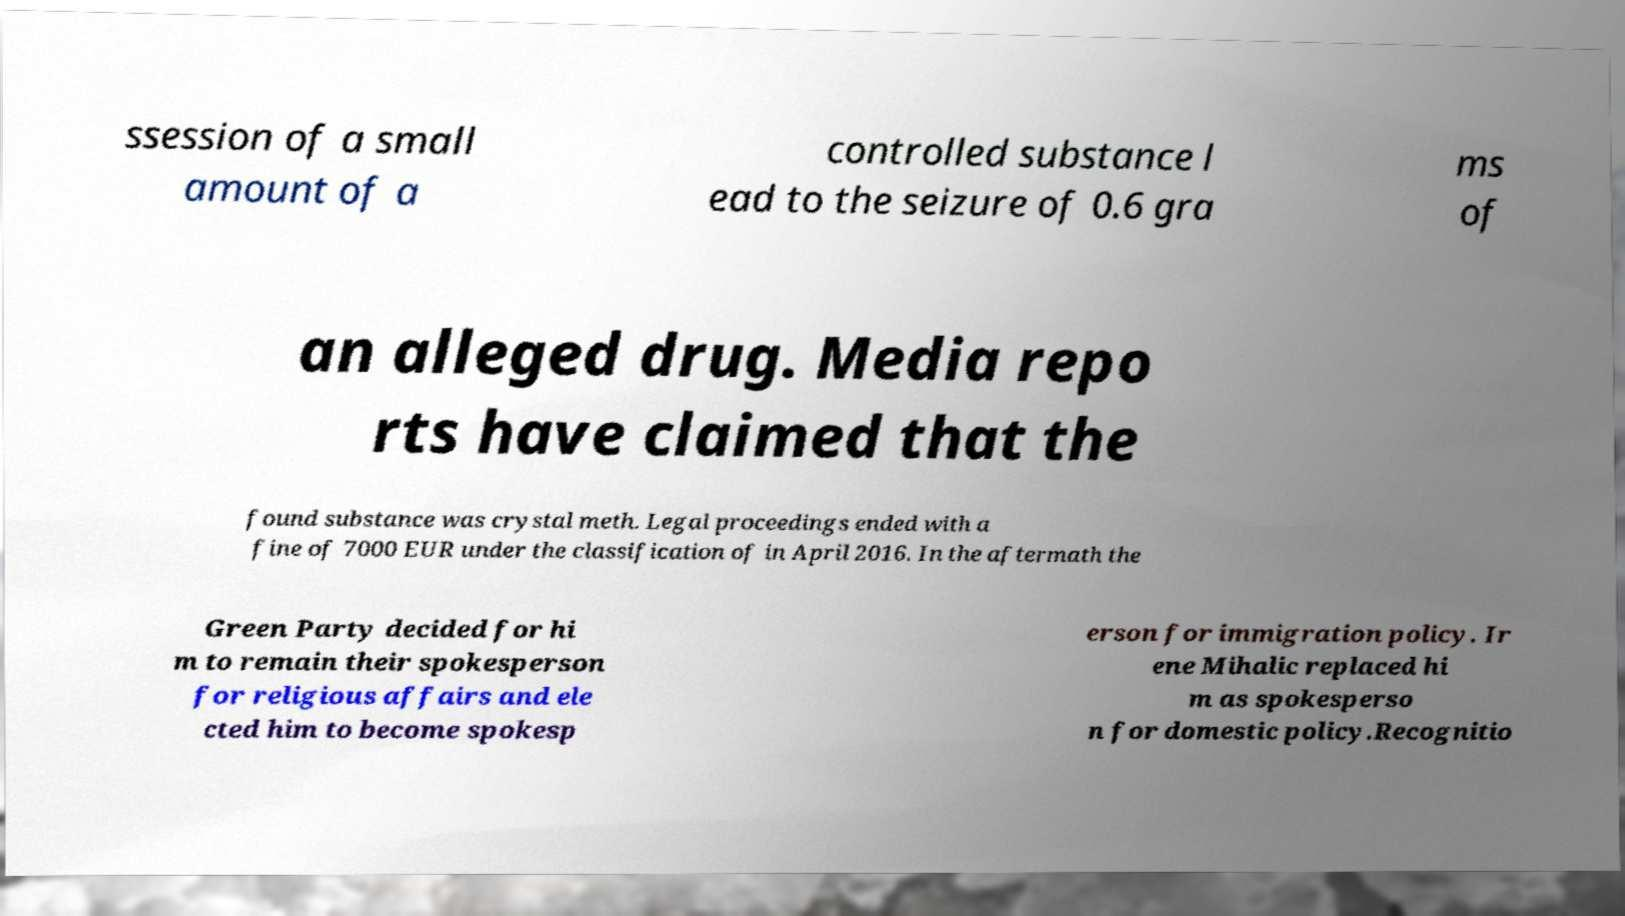For documentation purposes, I need the text within this image transcribed. Could you provide that? ssession of a small amount of a controlled substance l ead to the seizure of 0.6 gra ms of an alleged drug. Media repo rts have claimed that the found substance was crystal meth. Legal proceedings ended with a fine of 7000 EUR under the classification of in April 2016. In the aftermath the Green Party decided for hi m to remain their spokesperson for religious affairs and ele cted him to become spokesp erson for immigration policy. Ir ene Mihalic replaced hi m as spokesperso n for domestic policy.Recognitio 